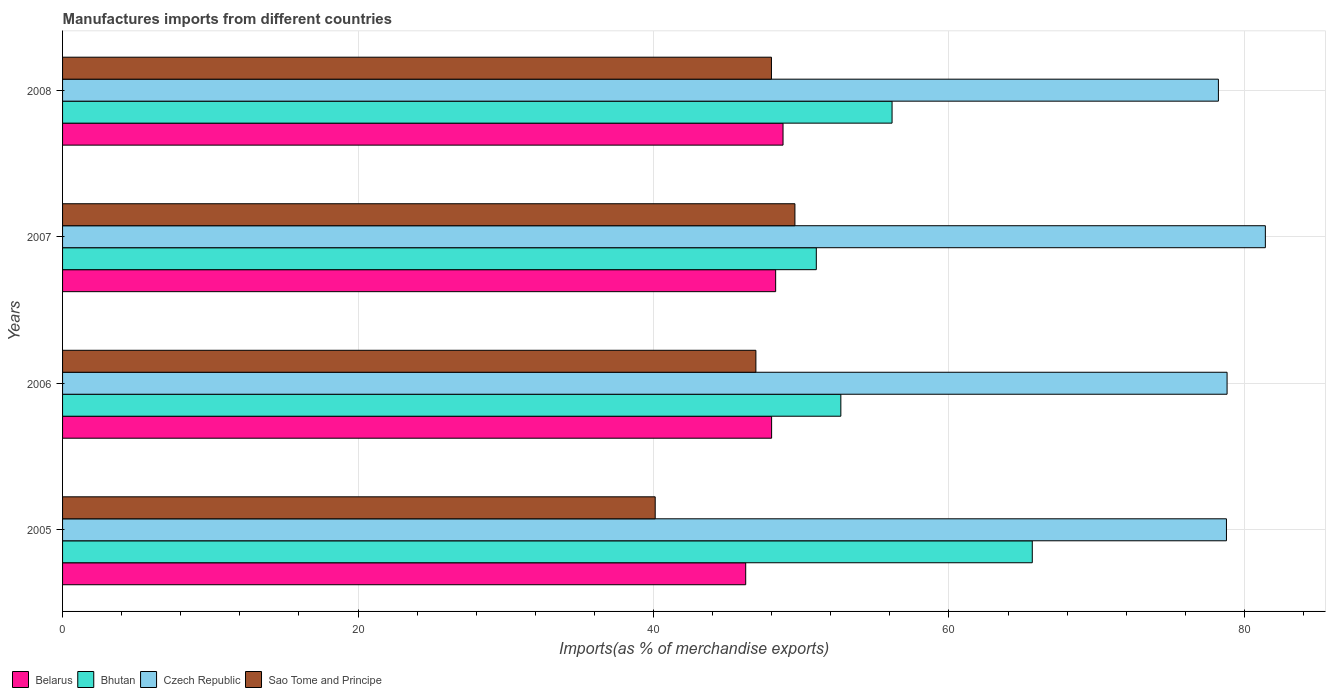How many groups of bars are there?
Your answer should be compact. 4. Are the number of bars on each tick of the Y-axis equal?
Keep it short and to the point. Yes. What is the percentage of imports to different countries in Czech Republic in 2008?
Offer a very short reply. 78.24. Across all years, what is the maximum percentage of imports to different countries in Bhutan?
Offer a very short reply. 65.64. Across all years, what is the minimum percentage of imports to different countries in Belarus?
Offer a terse response. 46.24. In which year was the percentage of imports to different countries in Belarus minimum?
Give a very brief answer. 2005. What is the total percentage of imports to different countries in Belarus in the graph?
Your answer should be compact. 191.27. What is the difference between the percentage of imports to different countries in Bhutan in 2005 and that in 2008?
Ensure brevity in your answer.  9.49. What is the difference between the percentage of imports to different countries in Sao Tome and Principe in 2006 and the percentage of imports to different countries in Bhutan in 2005?
Your answer should be compact. -18.71. What is the average percentage of imports to different countries in Bhutan per year?
Provide a succinct answer. 56.37. In the year 2006, what is the difference between the percentage of imports to different countries in Czech Republic and percentage of imports to different countries in Belarus?
Offer a very short reply. 30.83. In how many years, is the percentage of imports to different countries in Belarus greater than 28 %?
Ensure brevity in your answer.  4. What is the ratio of the percentage of imports to different countries in Czech Republic in 2005 to that in 2008?
Provide a succinct answer. 1.01. Is the percentage of imports to different countries in Bhutan in 2006 less than that in 2008?
Provide a succinct answer. Yes. What is the difference between the highest and the second highest percentage of imports to different countries in Belarus?
Ensure brevity in your answer.  0.5. What is the difference between the highest and the lowest percentage of imports to different countries in Bhutan?
Provide a succinct answer. 14.62. What does the 2nd bar from the top in 2005 represents?
Your response must be concise. Czech Republic. What does the 1st bar from the bottom in 2005 represents?
Offer a terse response. Belarus. How many bars are there?
Your response must be concise. 16. What is the difference between two consecutive major ticks on the X-axis?
Make the answer very short. 20. Does the graph contain grids?
Give a very brief answer. Yes. What is the title of the graph?
Provide a succinct answer. Manufactures imports from different countries. Does "Tuvalu" appear as one of the legend labels in the graph?
Provide a short and direct response. No. What is the label or title of the X-axis?
Provide a short and direct response. Imports(as % of merchandise exports). What is the label or title of the Y-axis?
Offer a terse response. Years. What is the Imports(as % of merchandise exports) of Belarus in 2005?
Give a very brief answer. 46.24. What is the Imports(as % of merchandise exports) of Bhutan in 2005?
Offer a terse response. 65.64. What is the Imports(as % of merchandise exports) in Czech Republic in 2005?
Make the answer very short. 78.78. What is the Imports(as % of merchandise exports) of Sao Tome and Principe in 2005?
Your answer should be very brief. 40.11. What is the Imports(as % of merchandise exports) in Belarus in 2006?
Ensure brevity in your answer.  47.99. What is the Imports(as % of merchandise exports) of Bhutan in 2006?
Give a very brief answer. 52.68. What is the Imports(as % of merchandise exports) in Czech Republic in 2006?
Keep it short and to the point. 78.82. What is the Imports(as % of merchandise exports) of Sao Tome and Principe in 2006?
Offer a terse response. 46.93. What is the Imports(as % of merchandise exports) in Belarus in 2007?
Give a very brief answer. 48.27. What is the Imports(as % of merchandise exports) in Bhutan in 2007?
Give a very brief answer. 51.02. What is the Imports(as % of merchandise exports) in Czech Republic in 2007?
Your answer should be compact. 81.41. What is the Imports(as % of merchandise exports) of Sao Tome and Principe in 2007?
Your answer should be compact. 49.57. What is the Imports(as % of merchandise exports) of Belarus in 2008?
Provide a short and direct response. 48.77. What is the Imports(as % of merchandise exports) of Bhutan in 2008?
Give a very brief answer. 56.15. What is the Imports(as % of merchandise exports) of Czech Republic in 2008?
Your answer should be very brief. 78.24. What is the Imports(as % of merchandise exports) in Sao Tome and Principe in 2008?
Provide a succinct answer. 47.98. Across all years, what is the maximum Imports(as % of merchandise exports) in Belarus?
Provide a succinct answer. 48.77. Across all years, what is the maximum Imports(as % of merchandise exports) in Bhutan?
Ensure brevity in your answer.  65.64. Across all years, what is the maximum Imports(as % of merchandise exports) of Czech Republic?
Your response must be concise. 81.41. Across all years, what is the maximum Imports(as % of merchandise exports) in Sao Tome and Principe?
Your answer should be compact. 49.57. Across all years, what is the minimum Imports(as % of merchandise exports) in Belarus?
Provide a short and direct response. 46.24. Across all years, what is the minimum Imports(as % of merchandise exports) of Bhutan?
Provide a succinct answer. 51.02. Across all years, what is the minimum Imports(as % of merchandise exports) in Czech Republic?
Keep it short and to the point. 78.24. Across all years, what is the minimum Imports(as % of merchandise exports) in Sao Tome and Principe?
Provide a short and direct response. 40.11. What is the total Imports(as % of merchandise exports) in Belarus in the graph?
Keep it short and to the point. 191.27. What is the total Imports(as % of merchandise exports) in Bhutan in the graph?
Offer a very short reply. 225.49. What is the total Imports(as % of merchandise exports) in Czech Republic in the graph?
Keep it short and to the point. 317.26. What is the total Imports(as % of merchandise exports) of Sao Tome and Principe in the graph?
Ensure brevity in your answer.  184.6. What is the difference between the Imports(as % of merchandise exports) of Belarus in 2005 and that in 2006?
Your answer should be compact. -1.75. What is the difference between the Imports(as % of merchandise exports) of Bhutan in 2005 and that in 2006?
Your answer should be compact. 12.96. What is the difference between the Imports(as % of merchandise exports) in Czech Republic in 2005 and that in 2006?
Provide a succinct answer. -0.04. What is the difference between the Imports(as % of merchandise exports) in Sao Tome and Principe in 2005 and that in 2006?
Keep it short and to the point. -6.82. What is the difference between the Imports(as % of merchandise exports) in Belarus in 2005 and that in 2007?
Your answer should be compact. -2.03. What is the difference between the Imports(as % of merchandise exports) in Bhutan in 2005 and that in 2007?
Your answer should be very brief. 14.62. What is the difference between the Imports(as % of merchandise exports) in Czech Republic in 2005 and that in 2007?
Provide a short and direct response. -2.63. What is the difference between the Imports(as % of merchandise exports) of Sao Tome and Principe in 2005 and that in 2007?
Give a very brief answer. -9.46. What is the difference between the Imports(as % of merchandise exports) of Belarus in 2005 and that in 2008?
Offer a terse response. -2.53. What is the difference between the Imports(as % of merchandise exports) of Bhutan in 2005 and that in 2008?
Keep it short and to the point. 9.49. What is the difference between the Imports(as % of merchandise exports) in Czech Republic in 2005 and that in 2008?
Provide a short and direct response. 0.54. What is the difference between the Imports(as % of merchandise exports) in Sao Tome and Principe in 2005 and that in 2008?
Make the answer very short. -7.87. What is the difference between the Imports(as % of merchandise exports) of Belarus in 2006 and that in 2007?
Your answer should be very brief. -0.27. What is the difference between the Imports(as % of merchandise exports) of Bhutan in 2006 and that in 2007?
Offer a very short reply. 1.66. What is the difference between the Imports(as % of merchandise exports) in Czech Republic in 2006 and that in 2007?
Offer a terse response. -2.59. What is the difference between the Imports(as % of merchandise exports) in Sao Tome and Principe in 2006 and that in 2007?
Your response must be concise. -2.64. What is the difference between the Imports(as % of merchandise exports) of Belarus in 2006 and that in 2008?
Keep it short and to the point. -0.77. What is the difference between the Imports(as % of merchandise exports) in Bhutan in 2006 and that in 2008?
Offer a very short reply. -3.47. What is the difference between the Imports(as % of merchandise exports) in Czech Republic in 2006 and that in 2008?
Your answer should be very brief. 0.59. What is the difference between the Imports(as % of merchandise exports) in Sao Tome and Principe in 2006 and that in 2008?
Your answer should be compact. -1.05. What is the difference between the Imports(as % of merchandise exports) in Belarus in 2007 and that in 2008?
Give a very brief answer. -0.5. What is the difference between the Imports(as % of merchandise exports) in Bhutan in 2007 and that in 2008?
Provide a short and direct response. -5.13. What is the difference between the Imports(as % of merchandise exports) of Czech Republic in 2007 and that in 2008?
Offer a very short reply. 3.18. What is the difference between the Imports(as % of merchandise exports) in Sao Tome and Principe in 2007 and that in 2008?
Your response must be concise. 1.59. What is the difference between the Imports(as % of merchandise exports) of Belarus in 2005 and the Imports(as % of merchandise exports) of Bhutan in 2006?
Keep it short and to the point. -6.44. What is the difference between the Imports(as % of merchandise exports) of Belarus in 2005 and the Imports(as % of merchandise exports) of Czech Republic in 2006?
Your response must be concise. -32.58. What is the difference between the Imports(as % of merchandise exports) of Belarus in 2005 and the Imports(as % of merchandise exports) of Sao Tome and Principe in 2006?
Keep it short and to the point. -0.69. What is the difference between the Imports(as % of merchandise exports) of Bhutan in 2005 and the Imports(as % of merchandise exports) of Czech Republic in 2006?
Keep it short and to the point. -13.19. What is the difference between the Imports(as % of merchandise exports) of Bhutan in 2005 and the Imports(as % of merchandise exports) of Sao Tome and Principe in 2006?
Offer a terse response. 18.71. What is the difference between the Imports(as % of merchandise exports) of Czech Republic in 2005 and the Imports(as % of merchandise exports) of Sao Tome and Principe in 2006?
Provide a succinct answer. 31.85. What is the difference between the Imports(as % of merchandise exports) of Belarus in 2005 and the Imports(as % of merchandise exports) of Bhutan in 2007?
Provide a short and direct response. -4.78. What is the difference between the Imports(as % of merchandise exports) of Belarus in 2005 and the Imports(as % of merchandise exports) of Czech Republic in 2007?
Provide a succinct answer. -35.17. What is the difference between the Imports(as % of merchandise exports) in Belarus in 2005 and the Imports(as % of merchandise exports) in Sao Tome and Principe in 2007?
Make the answer very short. -3.33. What is the difference between the Imports(as % of merchandise exports) in Bhutan in 2005 and the Imports(as % of merchandise exports) in Czech Republic in 2007?
Provide a succinct answer. -15.78. What is the difference between the Imports(as % of merchandise exports) of Bhutan in 2005 and the Imports(as % of merchandise exports) of Sao Tome and Principe in 2007?
Provide a succinct answer. 16.07. What is the difference between the Imports(as % of merchandise exports) in Czech Republic in 2005 and the Imports(as % of merchandise exports) in Sao Tome and Principe in 2007?
Offer a terse response. 29.21. What is the difference between the Imports(as % of merchandise exports) in Belarus in 2005 and the Imports(as % of merchandise exports) in Bhutan in 2008?
Provide a succinct answer. -9.91. What is the difference between the Imports(as % of merchandise exports) of Belarus in 2005 and the Imports(as % of merchandise exports) of Czech Republic in 2008?
Offer a terse response. -32. What is the difference between the Imports(as % of merchandise exports) of Belarus in 2005 and the Imports(as % of merchandise exports) of Sao Tome and Principe in 2008?
Keep it short and to the point. -1.74. What is the difference between the Imports(as % of merchandise exports) of Bhutan in 2005 and the Imports(as % of merchandise exports) of Czech Republic in 2008?
Your response must be concise. -12.6. What is the difference between the Imports(as % of merchandise exports) of Bhutan in 2005 and the Imports(as % of merchandise exports) of Sao Tome and Principe in 2008?
Provide a short and direct response. 17.65. What is the difference between the Imports(as % of merchandise exports) of Czech Republic in 2005 and the Imports(as % of merchandise exports) of Sao Tome and Principe in 2008?
Make the answer very short. 30.8. What is the difference between the Imports(as % of merchandise exports) in Belarus in 2006 and the Imports(as % of merchandise exports) in Bhutan in 2007?
Provide a short and direct response. -3.03. What is the difference between the Imports(as % of merchandise exports) of Belarus in 2006 and the Imports(as % of merchandise exports) of Czech Republic in 2007?
Offer a terse response. -33.42. What is the difference between the Imports(as % of merchandise exports) in Belarus in 2006 and the Imports(as % of merchandise exports) in Sao Tome and Principe in 2007?
Keep it short and to the point. -1.58. What is the difference between the Imports(as % of merchandise exports) of Bhutan in 2006 and the Imports(as % of merchandise exports) of Czech Republic in 2007?
Provide a short and direct response. -28.73. What is the difference between the Imports(as % of merchandise exports) in Bhutan in 2006 and the Imports(as % of merchandise exports) in Sao Tome and Principe in 2007?
Provide a short and direct response. 3.11. What is the difference between the Imports(as % of merchandise exports) in Czech Republic in 2006 and the Imports(as % of merchandise exports) in Sao Tome and Principe in 2007?
Make the answer very short. 29.25. What is the difference between the Imports(as % of merchandise exports) of Belarus in 2006 and the Imports(as % of merchandise exports) of Bhutan in 2008?
Provide a short and direct response. -8.15. What is the difference between the Imports(as % of merchandise exports) in Belarus in 2006 and the Imports(as % of merchandise exports) in Czech Republic in 2008?
Provide a succinct answer. -30.24. What is the difference between the Imports(as % of merchandise exports) in Belarus in 2006 and the Imports(as % of merchandise exports) in Sao Tome and Principe in 2008?
Ensure brevity in your answer.  0.01. What is the difference between the Imports(as % of merchandise exports) of Bhutan in 2006 and the Imports(as % of merchandise exports) of Czech Republic in 2008?
Give a very brief answer. -25.56. What is the difference between the Imports(as % of merchandise exports) in Bhutan in 2006 and the Imports(as % of merchandise exports) in Sao Tome and Principe in 2008?
Offer a very short reply. 4.7. What is the difference between the Imports(as % of merchandise exports) of Czech Republic in 2006 and the Imports(as % of merchandise exports) of Sao Tome and Principe in 2008?
Keep it short and to the point. 30.84. What is the difference between the Imports(as % of merchandise exports) in Belarus in 2007 and the Imports(as % of merchandise exports) in Bhutan in 2008?
Ensure brevity in your answer.  -7.88. What is the difference between the Imports(as % of merchandise exports) of Belarus in 2007 and the Imports(as % of merchandise exports) of Czech Republic in 2008?
Keep it short and to the point. -29.97. What is the difference between the Imports(as % of merchandise exports) of Belarus in 2007 and the Imports(as % of merchandise exports) of Sao Tome and Principe in 2008?
Your response must be concise. 0.28. What is the difference between the Imports(as % of merchandise exports) of Bhutan in 2007 and the Imports(as % of merchandise exports) of Czech Republic in 2008?
Give a very brief answer. -27.22. What is the difference between the Imports(as % of merchandise exports) in Bhutan in 2007 and the Imports(as % of merchandise exports) in Sao Tome and Principe in 2008?
Give a very brief answer. 3.04. What is the difference between the Imports(as % of merchandise exports) of Czech Republic in 2007 and the Imports(as % of merchandise exports) of Sao Tome and Principe in 2008?
Your answer should be compact. 33.43. What is the average Imports(as % of merchandise exports) in Belarus per year?
Give a very brief answer. 47.82. What is the average Imports(as % of merchandise exports) of Bhutan per year?
Keep it short and to the point. 56.37. What is the average Imports(as % of merchandise exports) of Czech Republic per year?
Make the answer very short. 79.31. What is the average Imports(as % of merchandise exports) of Sao Tome and Principe per year?
Ensure brevity in your answer.  46.15. In the year 2005, what is the difference between the Imports(as % of merchandise exports) in Belarus and Imports(as % of merchandise exports) in Bhutan?
Ensure brevity in your answer.  -19.4. In the year 2005, what is the difference between the Imports(as % of merchandise exports) of Belarus and Imports(as % of merchandise exports) of Czech Republic?
Offer a terse response. -32.54. In the year 2005, what is the difference between the Imports(as % of merchandise exports) in Belarus and Imports(as % of merchandise exports) in Sao Tome and Principe?
Offer a terse response. 6.13. In the year 2005, what is the difference between the Imports(as % of merchandise exports) of Bhutan and Imports(as % of merchandise exports) of Czech Republic?
Keep it short and to the point. -13.14. In the year 2005, what is the difference between the Imports(as % of merchandise exports) of Bhutan and Imports(as % of merchandise exports) of Sao Tome and Principe?
Provide a short and direct response. 25.52. In the year 2005, what is the difference between the Imports(as % of merchandise exports) in Czech Republic and Imports(as % of merchandise exports) in Sao Tome and Principe?
Your response must be concise. 38.67. In the year 2006, what is the difference between the Imports(as % of merchandise exports) in Belarus and Imports(as % of merchandise exports) in Bhutan?
Your answer should be compact. -4.69. In the year 2006, what is the difference between the Imports(as % of merchandise exports) in Belarus and Imports(as % of merchandise exports) in Czech Republic?
Make the answer very short. -30.83. In the year 2006, what is the difference between the Imports(as % of merchandise exports) of Belarus and Imports(as % of merchandise exports) of Sao Tome and Principe?
Make the answer very short. 1.06. In the year 2006, what is the difference between the Imports(as % of merchandise exports) in Bhutan and Imports(as % of merchandise exports) in Czech Republic?
Offer a very short reply. -26.14. In the year 2006, what is the difference between the Imports(as % of merchandise exports) of Bhutan and Imports(as % of merchandise exports) of Sao Tome and Principe?
Offer a very short reply. 5.75. In the year 2006, what is the difference between the Imports(as % of merchandise exports) of Czech Republic and Imports(as % of merchandise exports) of Sao Tome and Principe?
Your answer should be very brief. 31.89. In the year 2007, what is the difference between the Imports(as % of merchandise exports) in Belarus and Imports(as % of merchandise exports) in Bhutan?
Give a very brief answer. -2.75. In the year 2007, what is the difference between the Imports(as % of merchandise exports) in Belarus and Imports(as % of merchandise exports) in Czech Republic?
Make the answer very short. -33.15. In the year 2007, what is the difference between the Imports(as % of merchandise exports) of Belarus and Imports(as % of merchandise exports) of Sao Tome and Principe?
Give a very brief answer. -1.3. In the year 2007, what is the difference between the Imports(as % of merchandise exports) in Bhutan and Imports(as % of merchandise exports) in Czech Republic?
Your response must be concise. -30.39. In the year 2007, what is the difference between the Imports(as % of merchandise exports) of Bhutan and Imports(as % of merchandise exports) of Sao Tome and Principe?
Keep it short and to the point. 1.45. In the year 2007, what is the difference between the Imports(as % of merchandise exports) in Czech Republic and Imports(as % of merchandise exports) in Sao Tome and Principe?
Give a very brief answer. 31.84. In the year 2008, what is the difference between the Imports(as % of merchandise exports) of Belarus and Imports(as % of merchandise exports) of Bhutan?
Provide a short and direct response. -7.38. In the year 2008, what is the difference between the Imports(as % of merchandise exports) of Belarus and Imports(as % of merchandise exports) of Czech Republic?
Your answer should be compact. -29.47. In the year 2008, what is the difference between the Imports(as % of merchandise exports) in Belarus and Imports(as % of merchandise exports) in Sao Tome and Principe?
Provide a succinct answer. 0.78. In the year 2008, what is the difference between the Imports(as % of merchandise exports) in Bhutan and Imports(as % of merchandise exports) in Czech Republic?
Provide a succinct answer. -22.09. In the year 2008, what is the difference between the Imports(as % of merchandise exports) in Bhutan and Imports(as % of merchandise exports) in Sao Tome and Principe?
Your answer should be very brief. 8.16. In the year 2008, what is the difference between the Imports(as % of merchandise exports) in Czech Republic and Imports(as % of merchandise exports) in Sao Tome and Principe?
Provide a succinct answer. 30.25. What is the ratio of the Imports(as % of merchandise exports) of Belarus in 2005 to that in 2006?
Offer a very short reply. 0.96. What is the ratio of the Imports(as % of merchandise exports) of Bhutan in 2005 to that in 2006?
Provide a succinct answer. 1.25. What is the ratio of the Imports(as % of merchandise exports) in Sao Tome and Principe in 2005 to that in 2006?
Keep it short and to the point. 0.85. What is the ratio of the Imports(as % of merchandise exports) in Belarus in 2005 to that in 2007?
Offer a very short reply. 0.96. What is the ratio of the Imports(as % of merchandise exports) in Bhutan in 2005 to that in 2007?
Your response must be concise. 1.29. What is the ratio of the Imports(as % of merchandise exports) in Sao Tome and Principe in 2005 to that in 2007?
Your answer should be compact. 0.81. What is the ratio of the Imports(as % of merchandise exports) of Belarus in 2005 to that in 2008?
Ensure brevity in your answer.  0.95. What is the ratio of the Imports(as % of merchandise exports) in Bhutan in 2005 to that in 2008?
Offer a very short reply. 1.17. What is the ratio of the Imports(as % of merchandise exports) in Czech Republic in 2005 to that in 2008?
Ensure brevity in your answer.  1.01. What is the ratio of the Imports(as % of merchandise exports) in Sao Tome and Principe in 2005 to that in 2008?
Ensure brevity in your answer.  0.84. What is the ratio of the Imports(as % of merchandise exports) of Belarus in 2006 to that in 2007?
Your answer should be very brief. 0.99. What is the ratio of the Imports(as % of merchandise exports) in Bhutan in 2006 to that in 2007?
Your answer should be very brief. 1.03. What is the ratio of the Imports(as % of merchandise exports) of Czech Republic in 2006 to that in 2007?
Give a very brief answer. 0.97. What is the ratio of the Imports(as % of merchandise exports) in Sao Tome and Principe in 2006 to that in 2007?
Offer a terse response. 0.95. What is the ratio of the Imports(as % of merchandise exports) in Belarus in 2006 to that in 2008?
Your answer should be compact. 0.98. What is the ratio of the Imports(as % of merchandise exports) of Bhutan in 2006 to that in 2008?
Provide a short and direct response. 0.94. What is the ratio of the Imports(as % of merchandise exports) in Czech Republic in 2006 to that in 2008?
Ensure brevity in your answer.  1.01. What is the ratio of the Imports(as % of merchandise exports) in Belarus in 2007 to that in 2008?
Your answer should be very brief. 0.99. What is the ratio of the Imports(as % of merchandise exports) in Bhutan in 2007 to that in 2008?
Provide a short and direct response. 0.91. What is the ratio of the Imports(as % of merchandise exports) of Czech Republic in 2007 to that in 2008?
Provide a short and direct response. 1.04. What is the ratio of the Imports(as % of merchandise exports) of Sao Tome and Principe in 2007 to that in 2008?
Offer a terse response. 1.03. What is the difference between the highest and the second highest Imports(as % of merchandise exports) of Belarus?
Ensure brevity in your answer.  0.5. What is the difference between the highest and the second highest Imports(as % of merchandise exports) of Bhutan?
Keep it short and to the point. 9.49. What is the difference between the highest and the second highest Imports(as % of merchandise exports) of Czech Republic?
Provide a short and direct response. 2.59. What is the difference between the highest and the second highest Imports(as % of merchandise exports) of Sao Tome and Principe?
Ensure brevity in your answer.  1.59. What is the difference between the highest and the lowest Imports(as % of merchandise exports) in Belarus?
Make the answer very short. 2.53. What is the difference between the highest and the lowest Imports(as % of merchandise exports) in Bhutan?
Ensure brevity in your answer.  14.62. What is the difference between the highest and the lowest Imports(as % of merchandise exports) in Czech Republic?
Offer a very short reply. 3.18. What is the difference between the highest and the lowest Imports(as % of merchandise exports) in Sao Tome and Principe?
Your response must be concise. 9.46. 